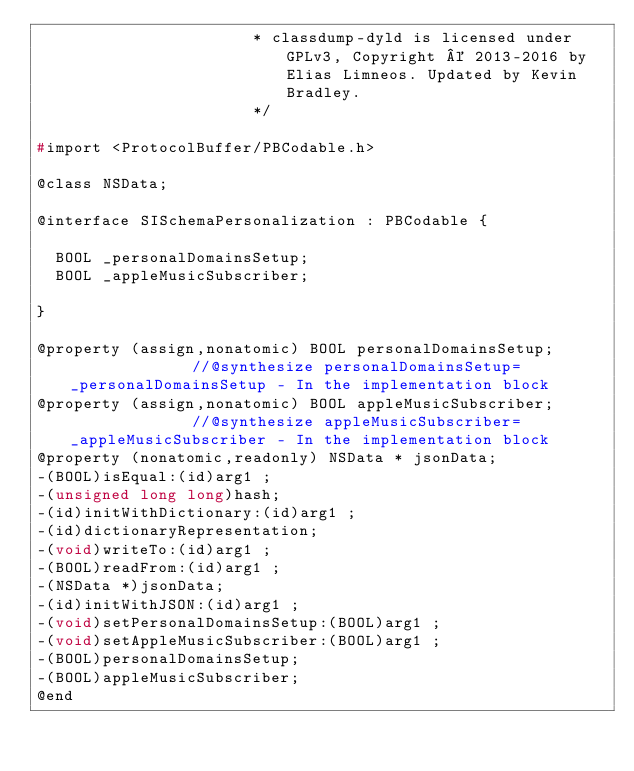Convert code to text. <code><loc_0><loc_0><loc_500><loc_500><_C_>                       * classdump-dyld is licensed under GPLv3, Copyright © 2013-2016 by Elias Limneos. Updated by Kevin Bradley.
                       */

#import <ProtocolBuffer/PBCodable.h>

@class NSData;

@interface SISchemaPersonalization : PBCodable {

	BOOL _personalDomainsSetup;
	BOOL _appleMusicSubscriber;

}

@property (assign,nonatomic) BOOL personalDomainsSetup;              //@synthesize personalDomainsSetup=_personalDomainsSetup - In the implementation block
@property (assign,nonatomic) BOOL appleMusicSubscriber;              //@synthesize appleMusicSubscriber=_appleMusicSubscriber - In the implementation block
@property (nonatomic,readonly) NSData * jsonData; 
-(BOOL)isEqual:(id)arg1 ;
-(unsigned long long)hash;
-(id)initWithDictionary:(id)arg1 ;
-(id)dictionaryRepresentation;
-(void)writeTo:(id)arg1 ;
-(BOOL)readFrom:(id)arg1 ;
-(NSData *)jsonData;
-(id)initWithJSON:(id)arg1 ;
-(void)setPersonalDomainsSetup:(BOOL)arg1 ;
-(void)setAppleMusicSubscriber:(BOOL)arg1 ;
-(BOOL)personalDomainsSetup;
-(BOOL)appleMusicSubscriber;
@end

</code> 